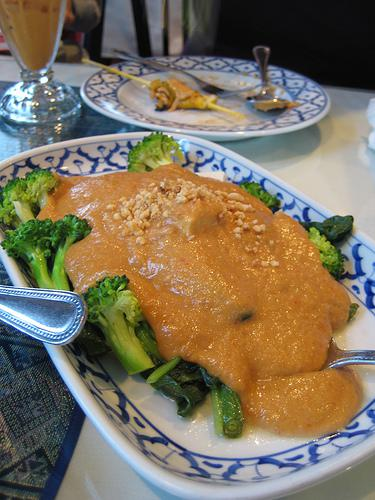Question: why is the food placed on the plate?
Choices:
A. To serve it.
B. To be eaten.
C. For decoration.
D. To have it in one place.
Answer with the letter. Answer: B Question: when was the food prepared?
Choices:
A. Last night.
B. Recently.
C. A few hours ago.
D. It hasn't been yet.
Answer with the letter. Answer: B Question: where is this picture taken?
Choices:
A. In the kitchen.
B. In a restaurant.
C. In an office.
D. At a mall.
Answer with the letter. Answer: B Question: what is on the square plate?
Choices:
A. Broccoli.
B. Dessert.
C. Cake.
D. Bread.
Answer with the letter. Answer: A 